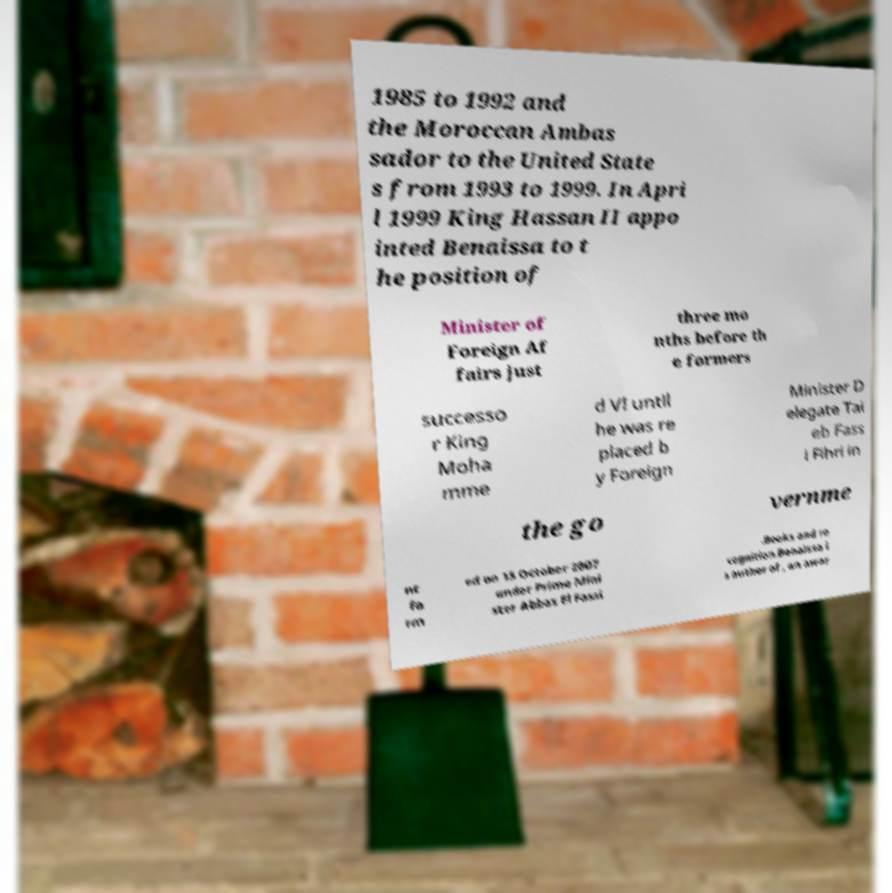Please identify and transcribe the text found in this image. 1985 to 1992 and the Moroccan Ambas sador to the United State s from 1993 to 1999. In Apri l 1999 King Hassan II appo inted Benaissa to t he position of Minister of Foreign Af fairs just three mo nths before th e formers successo r King Moha mme d VI until he was re placed b y Foreign Minister D elegate Tai eb Fass i Fihri in the go vernme nt fo rm ed on 15 October 2007 under Prime Mini ster Abbas El Fassi .Books and re cognition.Benaissa i s author of , an awar 